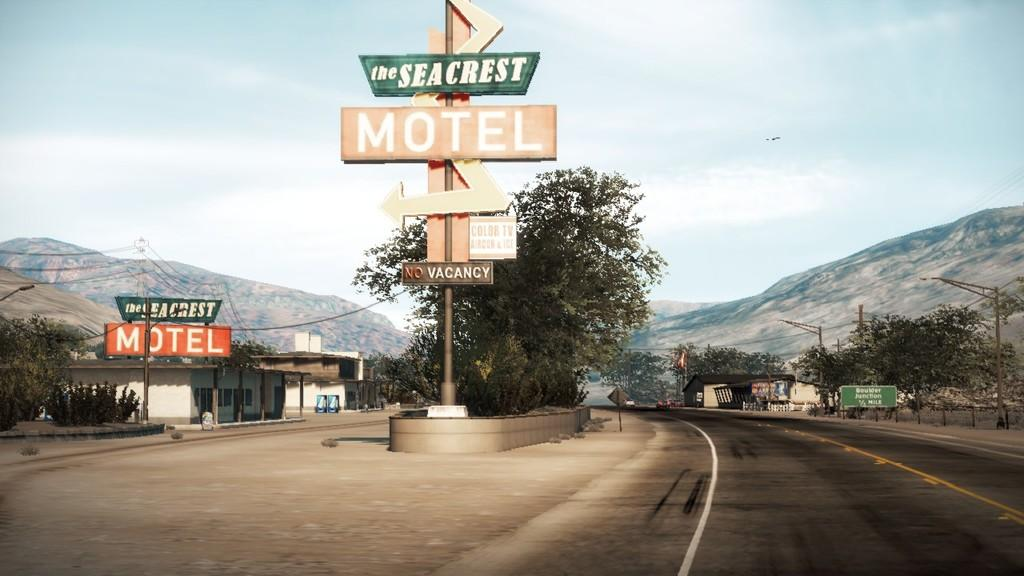<image>
Provide a brief description of the given image. A sign reading the Seacrest Motel alongside an empty road. 